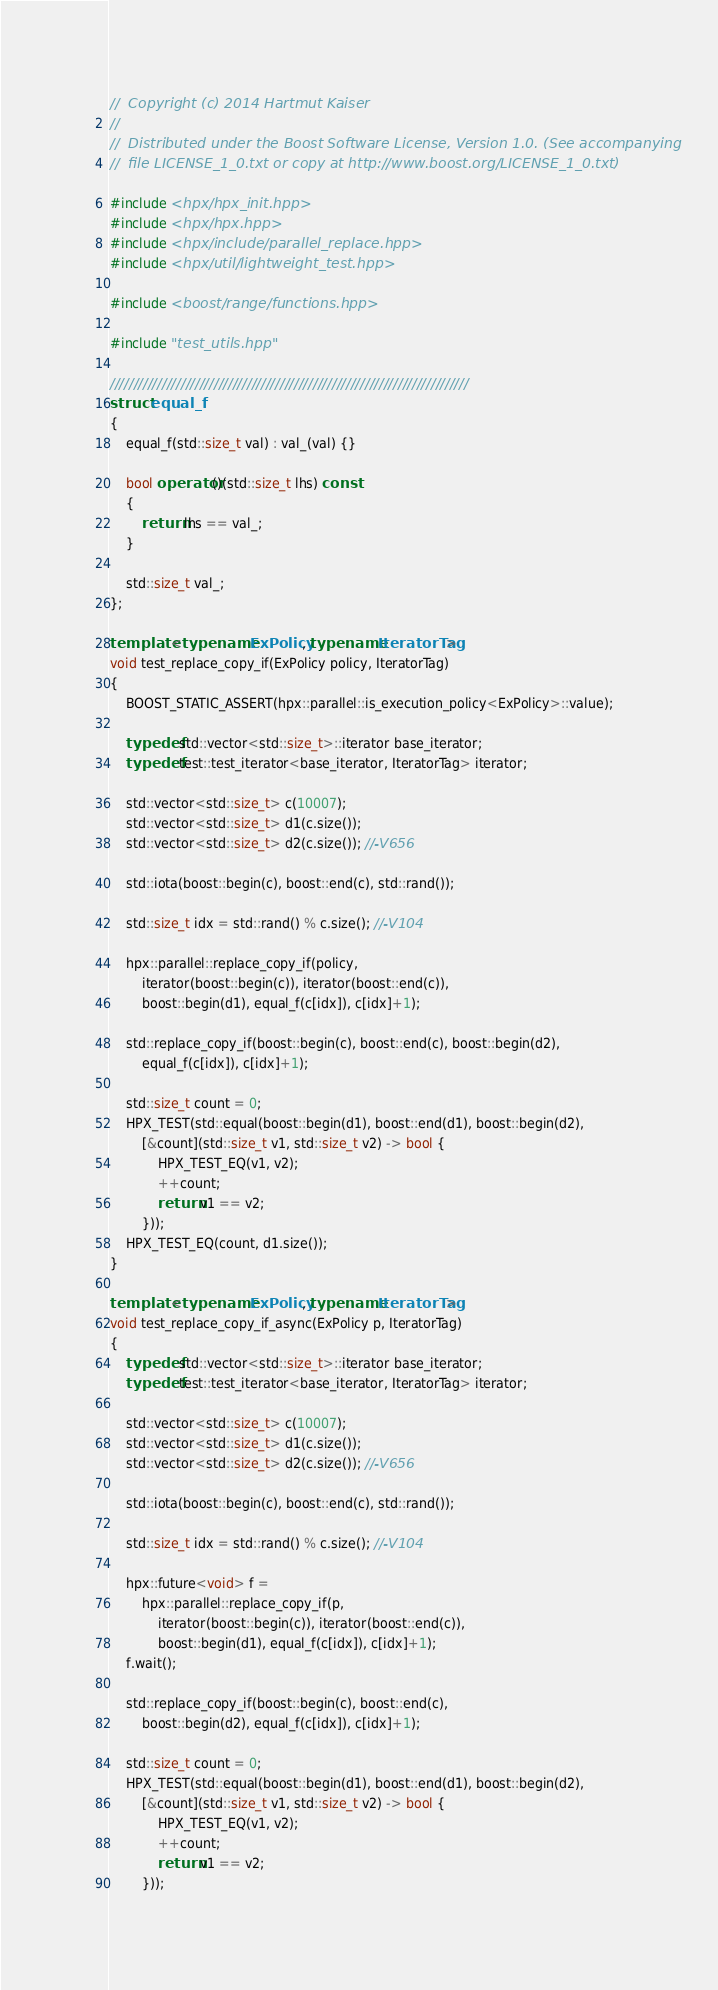Convert code to text. <code><loc_0><loc_0><loc_500><loc_500><_C++_>//  Copyright (c) 2014 Hartmut Kaiser
//
//  Distributed under the Boost Software License, Version 1.0. (See accompanying
//  file LICENSE_1_0.txt or copy at http://www.boost.org/LICENSE_1_0.txt)

#include <hpx/hpx_init.hpp>
#include <hpx/hpx.hpp>
#include <hpx/include/parallel_replace.hpp>
#include <hpx/util/lightweight_test.hpp>

#include <boost/range/functions.hpp>

#include "test_utils.hpp"

////////////////////////////////////////////////////////////////////////////
struct equal_f
{
    equal_f(std::size_t val) : val_(val) {}

    bool operator()(std::size_t lhs) const
    {
        return lhs == val_;
    }

    std::size_t val_;
};

template <typename ExPolicy, typename IteratorTag>
void test_replace_copy_if(ExPolicy policy, IteratorTag)
{
    BOOST_STATIC_ASSERT(hpx::parallel::is_execution_policy<ExPolicy>::value);

    typedef std::vector<std::size_t>::iterator base_iterator;
    typedef test::test_iterator<base_iterator, IteratorTag> iterator;

    std::vector<std::size_t> c(10007);
    std::vector<std::size_t> d1(c.size());
    std::vector<std::size_t> d2(c.size()); //-V656

    std::iota(boost::begin(c), boost::end(c), std::rand());

    std::size_t idx = std::rand() % c.size(); //-V104

    hpx::parallel::replace_copy_if(policy,
        iterator(boost::begin(c)), iterator(boost::end(c)),
        boost::begin(d1), equal_f(c[idx]), c[idx]+1);

    std::replace_copy_if(boost::begin(c), boost::end(c), boost::begin(d2),
        equal_f(c[idx]), c[idx]+1);

    std::size_t count = 0;
    HPX_TEST(std::equal(boost::begin(d1), boost::end(d1), boost::begin(d2),
        [&count](std::size_t v1, std::size_t v2) -> bool {
            HPX_TEST_EQ(v1, v2);
            ++count;
            return v1 == v2;
        }));
    HPX_TEST_EQ(count, d1.size());
}

template <typename ExPolicy, typename IteratorTag>
void test_replace_copy_if_async(ExPolicy p, IteratorTag)
{
    typedef std::vector<std::size_t>::iterator base_iterator;
    typedef test::test_iterator<base_iterator, IteratorTag> iterator;

    std::vector<std::size_t> c(10007);
    std::vector<std::size_t> d1(c.size());
    std::vector<std::size_t> d2(c.size()); //-V656

    std::iota(boost::begin(c), boost::end(c), std::rand());

    std::size_t idx = std::rand() % c.size(); //-V104

    hpx::future<void> f =
        hpx::parallel::replace_copy_if(p,
            iterator(boost::begin(c)), iterator(boost::end(c)),
            boost::begin(d1), equal_f(c[idx]), c[idx]+1);
    f.wait();

    std::replace_copy_if(boost::begin(c), boost::end(c),
        boost::begin(d2), equal_f(c[idx]), c[idx]+1);

    std::size_t count = 0;
    HPX_TEST(std::equal(boost::begin(d1), boost::end(d1), boost::begin(d2),
        [&count](std::size_t v1, std::size_t v2) -> bool {
            HPX_TEST_EQ(v1, v2);
            ++count;
            return v1 == v2;
        }));</code> 